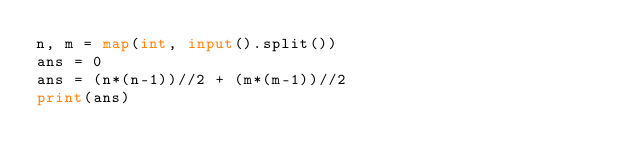<code> <loc_0><loc_0><loc_500><loc_500><_Python_>n, m = map(int, input().split())
ans = 0
ans = (n*(n-1))//2 + (m*(m-1))//2
print(ans)
</code> 